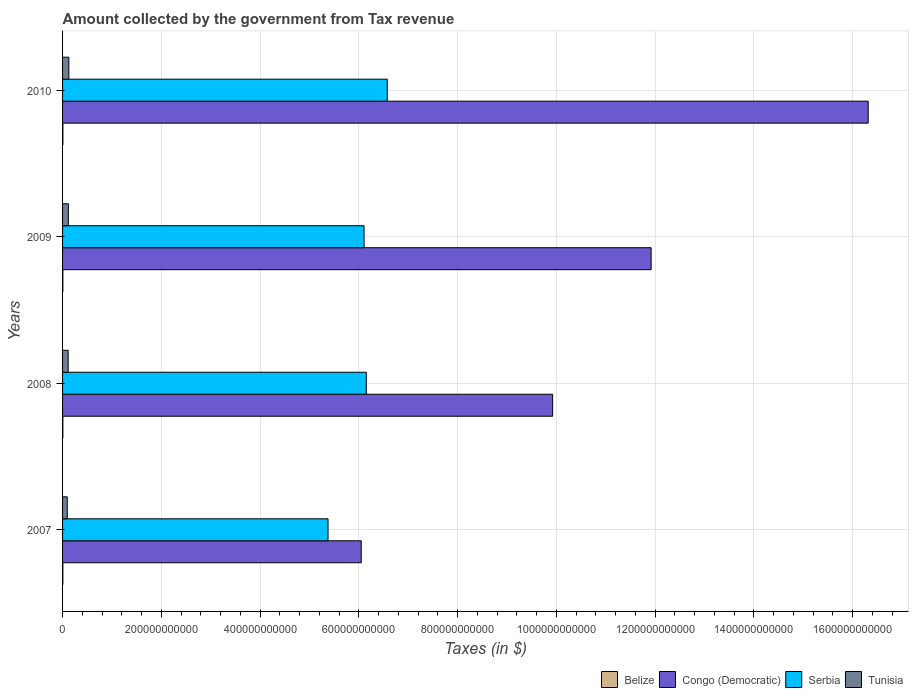What is the label of the 4th group of bars from the top?
Keep it short and to the point. 2007. In how many cases, is the number of bars for a given year not equal to the number of legend labels?
Keep it short and to the point. 0. What is the amount collected by the government from tax revenue in Tunisia in 2009?
Your answer should be compact. 1.18e+1. Across all years, what is the maximum amount collected by the government from tax revenue in Tunisia?
Provide a short and direct response. 1.27e+1. Across all years, what is the minimum amount collected by the government from tax revenue in Tunisia?
Offer a terse response. 9.51e+09. In which year was the amount collected by the government from tax revenue in Tunisia maximum?
Your answer should be compact. 2010. What is the total amount collected by the government from tax revenue in Belize in the graph?
Your response must be concise. 2.45e+09. What is the difference between the amount collected by the government from tax revenue in Serbia in 2009 and that in 2010?
Make the answer very short. -4.70e+1. What is the difference between the amount collected by the government from tax revenue in Serbia in 2010 and the amount collected by the government from tax revenue in Congo (Democratic) in 2008?
Provide a succinct answer. -3.35e+11. What is the average amount collected by the government from tax revenue in Serbia per year?
Give a very brief answer. 6.05e+11. In the year 2009, what is the difference between the amount collected by the government from tax revenue in Serbia and amount collected by the government from tax revenue in Belize?
Ensure brevity in your answer.  6.10e+11. What is the ratio of the amount collected by the government from tax revenue in Serbia in 2007 to that in 2010?
Your answer should be compact. 0.82. Is the amount collected by the government from tax revenue in Tunisia in 2009 less than that in 2010?
Your answer should be compact. Yes. Is the difference between the amount collected by the government from tax revenue in Serbia in 2007 and 2009 greater than the difference between the amount collected by the government from tax revenue in Belize in 2007 and 2009?
Your answer should be compact. No. What is the difference between the highest and the second highest amount collected by the government from tax revenue in Congo (Democratic)?
Give a very brief answer. 4.40e+11. What is the difference between the highest and the lowest amount collected by the government from tax revenue in Serbia?
Your response must be concise. 1.20e+11. In how many years, is the amount collected by the government from tax revenue in Belize greater than the average amount collected by the government from tax revenue in Belize taken over all years?
Your answer should be very brief. 1. Is it the case that in every year, the sum of the amount collected by the government from tax revenue in Belize and amount collected by the government from tax revenue in Congo (Democratic) is greater than the sum of amount collected by the government from tax revenue in Serbia and amount collected by the government from tax revenue in Tunisia?
Provide a short and direct response. Yes. What does the 2nd bar from the top in 2010 represents?
Make the answer very short. Serbia. What does the 3rd bar from the bottom in 2007 represents?
Make the answer very short. Serbia. Is it the case that in every year, the sum of the amount collected by the government from tax revenue in Serbia and amount collected by the government from tax revenue in Belize is greater than the amount collected by the government from tax revenue in Congo (Democratic)?
Provide a succinct answer. No. How many bars are there?
Your response must be concise. 16. Are all the bars in the graph horizontal?
Offer a very short reply. Yes. How many years are there in the graph?
Offer a terse response. 4. What is the difference between two consecutive major ticks on the X-axis?
Make the answer very short. 2.00e+11. What is the title of the graph?
Give a very brief answer. Amount collected by the government from Tax revenue. Does "Caribbean small states" appear as one of the legend labels in the graph?
Offer a terse response. No. What is the label or title of the X-axis?
Give a very brief answer. Taxes (in $). What is the Taxes (in $) in Belize in 2007?
Offer a terse response. 5.92e+08. What is the Taxes (in $) of Congo (Democratic) in 2007?
Offer a terse response. 6.05e+11. What is the Taxes (in $) of Serbia in 2007?
Keep it short and to the point. 5.38e+11. What is the Taxes (in $) in Tunisia in 2007?
Ensure brevity in your answer.  9.51e+09. What is the Taxes (in $) in Belize in 2008?
Make the answer very short. 5.94e+08. What is the Taxes (in $) of Congo (Democratic) in 2008?
Keep it short and to the point. 9.92e+11. What is the Taxes (in $) of Serbia in 2008?
Give a very brief answer. 6.15e+11. What is the Taxes (in $) in Tunisia in 2008?
Your answer should be compact. 1.13e+1. What is the Taxes (in $) of Belize in 2009?
Give a very brief answer. 6.01e+08. What is the Taxes (in $) in Congo (Democratic) in 2009?
Your response must be concise. 1.19e+12. What is the Taxes (in $) of Serbia in 2009?
Provide a short and direct response. 6.11e+11. What is the Taxes (in $) of Tunisia in 2009?
Keep it short and to the point. 1.18e+1. What is the Taxes (in $) of Belize in 2010?
Offer a terse response. 6.59e+08. What is the Taxes (in $) of Congo (Democratic) in 2010?
Keep it short and to the point. 1.63e+12. What is the Taxes (in $) in Serbia in 2010?
Your response must be concise. 6.58e+11. What is the Taxes (in $) in Tunisia in 2010?
Make the answer very short. 1.27e+1. Across all years, what is the maximum Taxes (in $) in Belize?
Provide a short and direct response. 6.59e+08. Across all years, what is the maximum Taxes (in $) in Congo (Democratic)?
Ensure brevity in your answer.  1.63e+12. Across all years, what is the maximum Taxes (in $) of Serbia?
Provide a short and direct response. 6.58e+11. Across all years, what is the maximum Taxes (in $) in Tunisia?
Provide a succinct answer. 1.27e+1. Across all years, what is the minimum Taxes (in $) in Belize?
Keep it short and to the point. 5.92e+08. Across all years, what is the minimum Taxes (in $) of Congo (Democratic)?
Offer a terse response. 6.05e+11. Across all years, what is the minimum Taxes (in $) of Serbia?
Provide a short and direct response. 5.38e+11. Across all years, what is the minimum Taxes (in $) of Tunisia?
Your answer should be compact. 9.51e+09. What is the total Taxes (in $) in Belize in the graph?
Offer a very short reply. 2.45e+09. What is the total Taxes (in $) of Congo (Democratic) in the graph?
Your answer should be very brief. 4.42e+12. What is the total Taxes (in $) of Serbia in the graph?
Keep it short and to the point. 2.42e+12. What is the total Taxes (in $) in Tunisia in the graph?
Provide a succinct answer. 4.53e+1. What is the difference between the Taxes (in $) in Belize in 2007 and that in 2008?
Keep it short and to the point. -2.30e+06. What is the difference between the Taxes (in $) of Congo (Democratic) in 2007 and that in 2008?
Provide a short and direct response. -3.88e+11. What is the difference between the Taxes (in $) of Serbia in 2007 and that in 2008?
Offer a very short reply. -7.75e+1. What is the difference between the Taxes (in $) in Tunisia in 2007 and that in 2008?
Your answer should be compact. -1.82e+09. What is the difference between the Taxes (in $) in Belize in 2007 and that in 2009?
Make the answer very short. -9.46e+06. What is the difference between the Taxes (in $) in Congo (Democratic) in 2007 and that in 2009?
Provide a short and direct response. -5.87e+11. What is the difference between the Taxes (in $) in Serbia in 2007 and that in 2009?
Give a very brief answer. -7.30e+1. What is the difference between the Taxes (in $) in Tunisia in 2007 and that in 2009?
Give a very brief answer. -2.26e+09. What is the difference between the Taxes (in $) of Belize in 2007 and that in 2010?
Your answer should be compact. -6.77e+07. What is the difference between the Taxes (in $) of Congo (Democratic) in 2007 and that in 2010?
Provide a short and direct response. -1.03e+12. What is the difference between the Taxes (in $) of Serbia in 2007 and that in 2010?
Your answer should be very brief. -1.20e+11. What is the difference between the Taxes (in $) of Tunisia in 2007 and that in 2010?
Offer a very short reply. -3.19e+09. What is the difference between the Taxes (in $) in Belize in 2008 and that in 2009?
Your answer should be compact. -7.17e+06. What is the difference between the Taxes (in $) in Congo (Democratic) in 2008 and that in 2009?
Your answer should be very brief. -1.99e+11. What is the difference between the Taxes (in $) in Serbia in 2008 and that in 2009?
Make the answer very short. 4.50e+09. What is the difference between the Taxes (in $) of Tunisia in 2008 and that in 2009?
Ensure brevity in your answer.  -4.33e+08. What is the difference between the Taxes (in $) of Belize in 2008 and that in 2010?
Make the answer very short. -6.54e+07. What is the difference between the Taxes (in $) in Congo (Democratic) in 2008 and that in 2010?
Offer a very short reply. -6.39e+11. What is the difference between the Taxes (in $) in Serbia in 2008 and that in 2010?
Provide a short and direct response. -4.25e+1. What is the difference between the Taxes (in $) in Tunisia in 2008 and that in 2010?
Keep it short and to the point. -1.37e+09. What is the difference between the Taxes (in $) of Belize in 2009 and that in 2010?
Your answer should be very brief. -5.82e+07. What is the difference between the Taxes (in $) in Congo (Democratic) in 2009 and that in 2010?
Your response must be concise. -4.40e+11. What is the difference between the Taxes (in $) of Serbia in 2009 and that in 2010?
Your response must be concise. -4.70e+1. What is the difference between the Taxes (in $) of Tunisia in 2009 and that in 2010?
Give a very brief answer. -9.35e+08. What is the difference between the Taxes (in $) in Belize in 2007 and the Taxes (in $) in Congo (Democratic) in 2008?
Offer a terse response. -9.92e+11. What is the difference between the Taxes (in $) in Belize in 2007 and the Taxes (in $) in Serbia in 2008?
Give a very brief answer. -6.14e+11. What is the difference between the Taxes (in $) of Belize in 2007 and the Taxes (in $) of Tunisia in 2008?
Your response must be concise. -1.07e+1. What is the difference between the Taxes (in $) in Congo (Democratic) in 2007 and the Taxes (in $) in Serbia in 2008?
Offer a very short reply. -1.03e+1. What is the difference between the Taxes (in $) in Congo (Democratic) in 2007 and the Taxes (in $) in Tunisia in 2008?
Keep it short and to the point. 5.93e+11. What is the difference between the Taxes (in $) of Serbia in 2007 and the Taxes (in $) of Tunisia in 2008?
Your response must be concise. 5.26e+11. What is the difference between the Taxes (in $) in Belize in 2007 and the Taxes (in $) in Congo (Democratic) in 2009?
Offer a terse response. -1.19e+12. What is the difference between the Taxes (in $) of Belize in 2007 and the Taxes (in $) of Serbia in 2009?
Ensure brevity in your answer.  -6.10e+11. What is the difference between the Taxes (in $) of Belize in 2007 and the Taxes (in $) of Tunisia in 2009?
Provide a succinct answer. -1.12e+1. What is the difference between the Taxes (in $) in Congo (Democratic) in 2007 and the Taxes (in $) in Serbia in 2009?
Provide a succinct answer. -5.83e+09. What is the difference between the Taxes (in $) in Congo (Democratic) in 2007 and the Taxes (in $) in Tunisia in 2009?
Make the answer very short. 5.93e+11. What is the difference between the Taxes (in $) in Serbia in 2007 and the Taxes (in $) in Tunisia in 2009?
Your response must be concise. 5.26e+11. What is the difference between the Taxes (in $) of Belize in 2007 and the Taxes (in $) of Congo (Democratic) in 2010?
Offer a terse response. -1.63e+12. What is the difference between the Taxes (in $) of Belize in 2007 and the Taxes (in $) of Serbia in 2010?
Your answer should be compact. -6.57e+11. What is the difference between the Taxes (in $) in Belize in 2007 and the Taxes (in $) in Tunisia in 2010?
Your answer should be very brief. -1.21e+1. What is the difference between the Taxes (in $) in Congo (Democratic) in 2007 and the Taxes (in $) in Serbia in 2010?
Offer a terse response. -5.28e+1. What is the difference between the Taxes (in $) of Congo (Democratic) in 2007 and the Taxes (in $) of Tunisia in 2010?
Offer a very short reply. 5.92e+11. What is the difference between the Taxes (in $) of Serbia in 2007 and the Taxes (in $) of Tunisia in 2010?
Your answer should be compact. 5.25e+11. What is the difference between the Taxes (in $) in Belize in 2008 and the Taxes (in $) in Congo (Democratic) in 2009?
Make the answer very short. -1.19e+12. What is the difference between the Taxes (in $) in Belize in 2008 and the Taxes (in $) in Serbia in 2009?
Give a very brief answer. -6.10e+11. What is the difference between the Taxes (in $) of Belize in 2008 and the Taxes (in $) of Tunisia in 2009?
Offer a very short reply. -1.12e+1. What is the difference between the Taxes (in $) of Congo (Democratic) in 2008 and the Taxes (in $) of Serbia in 2009?
Provide a succinct answer. 3.82e+11. What is the difference between the Taxes (in $) of Congo (Democratic) in 2008 and the Taxes (in $) of Tunisia in 2009?
Offer a terse response. 9.81e+11. What is the difference between the Taxes (in $) in Serbia in 2008 and the Taxes (in $) in Tunisia in 2009?
Provide a succinct answer. 6.03e+11. What is the difference between the Taxes (in $) in Belize in 2008 and the Taxes (in $) in Congo (Democratic) in 2010?
Offer a very short reply. -1.63e+12. What is the difference between the Taxes (in $) in Belize in 2008 and the Taxes (in $) in Serbia in 2010?
Your answer should be compact. -6.57e+11. What is the difference between the Taxes (in $) of Belize in 2008 and the Taxes (in $) of Tunisia in 2010?
Your answer should be compact. -1.21e+1. What is the difference between the Taxes (in $) of Congo (Democratic) in 2008 and the Taxes (in $) of Serbia in 2010?
Give a very brief answer. 3.35e+11. What is the difference between the Taxes (in $) in Congo (Democratic) in 2008 and the Taxes (in $) in Tunisia in 2010?
Keep it short and to the point. 9.80e+11. What is the difference between the Taxes (in $) in Serbia in 2008 and the Taxes (in $) in Tunisia in 2010?
Offer a very short reply. 6.02e+11. What is the difference between the Taxes (in $) of Belize in 2009 and the Taxes (in $) of Congo (Democratic) in 2010?
Your response must be concise. -1.63e+12. What is the difference between the Taxes (in $) of Belize in 2009 and the Taxes (in $) of Serbia in 2010?
Your answer should be compact. -6.57e+11. What is the difference between the Taxes (in $) in Belize in 2009 and the Taxes (in $) in Tunisia in 2010?
Your response must be concise. -1.21e+1. What is the difference between the Taxes (in $) of Congo (Democratic) in 2009 and the Taxes (in $) of Serbia in 2010?
Make the answer very short. 5.34e+11. What is the difference between the Taxes (in $) in Congo (Democratic) in 2009 and the Taxes (in $) in Tunisia in 2010?
Ensure brevity in your answer.  1.18e+12. What is the difference between the Taxes (in $) in Serbia in 2009 and the Taxes (in $) in Tunisia in 2010?
Provide a short and direct response. 5.98e+11. What is the average Taxes (in $) of Belize per year?
Offer a terse response. 6.12e+08. What is the average Taxes (in $) of Congo (Democratic) per year?
Ensure brevity in your answer.  1.11e+12. What is the average Taxes (in $) in Serbia per year?
Offer a terse response. 6.05e+11. What is the average Taxes (in $) in Tunisia per year?
Make the answer very short. 1.13e+1. In the year 2007, what is the difference between the Taxes (in $) in Belize and Taxes (in $) in Congo (Democratic)?
Ensure brevity in your answer.  -6.04e+11. In the year 2007, what is the difference between the Taxes (in $) of Belize and Taxes (in $) of Serbia?
Provide a succinct answer. -5.37e+11. In the year 2007, what is the difference between the Taxes (in $) of Belize and Taxes (in $) of Tunisia?
Your answer should be very brief. -8.92e+09. In the year 2007, what is the difference between the Taxes (in $) of Congo (Democratic) and Taxes (in $) of Serbia?
Give a very brief answer. 6.72e+1. In the year 2007, what is the difference between the Taxes (in $) of Congo (Democratic) and Taxes (in $) of Tunisia?
Your answer should be compact. 5.95e+11. In the year 2007, what is the difference between the Taxes (in $) of Serbia and Taxes (in $) of Tunisia?
Offer a terse response. 5.28e+11. In the year 2008, what is the difference between the Taxes (in $) in Belize and Taxes (in $) in Congo (Democratic)?
Offer a terse response. -9.92e+11. In the year 2008, what is the difference between the Taxes (in $) in Belize and Taxes (in $) in Serbia?
Your answer should be very brief. -6.14e+11. In the year 2008, what is the difference between the Taxes (in $) of Belize and Taxes (in $) of Tunisia?
Give a very brief answer. -1.07e+1. In the year 2008, what is the difference between the Taxes (in $) of Congo (Democratic) and Taxes (in $) of Serbia?
Your response must be concise. 3.77e+11. In the year 2008, what is the difference between the Taxes (in $) of Congo (Democratic) and Taxes (in $) of Tunisia?
Give a very brief answer. 9.81e+11. In the year 2008, what is the difference between the Taxes (in $) of Serbia and Taxes (in $) of Tunisia?
Give a very brief answer. 6.04e+11. In the year 2009, what is the difference between the Taxes (in $) of Belize and Taxes (in $) of Congo (Democratic)?
Your response must be concise. -1.19e+12. In the year 2009, what is the difference between the Taxes (in $) of Belize and Taxes (in $) of Serbia?
Give a very brief answer. -6.10e+11. In the year 2009, what is the difference between the Taxes (in $) in Belize and Taxes (in $) in Tunisia?
Provide a succinct answer. -1.12e+1. In the year 2009, what is the difference between the Taxes (in $) of Congo (Democratic) and Taxes (in $) of Serbia?
Your answer should be compact. 5.81e+11. In the year 2009, what is the difference between the Taxes (in $) of Congo (Democratic) and Taxes (in $) of Tunisia?
Your response must be concise. 1.18e+12. In the year 2009, what is the difference between the Taxes (in $) of Serbia and Taxes (in $) of Tunisia?
Your answer should be compact. 5.99e+11. In the year 2010, what is the difference between the Taxes (in $) in Belize and Taxes (in $) in Congo (Democratic)?
Offer a very short reply. -1.63e+12. In the year 2010, what is the difference between the Taxes (in $) in Belize and Taxes (in $) in Serbia?
Your answer should be compact. -6.57e+11. In the year 2010, what is the difference between the Taxes (in $) of Belize and Taxes (in $) of Tunisia?
Offer a terse response. -1.20e+1. In the year 2010, what is the difference between the Taxes (in $) of Congo (Democratic) and Taxes (in $) of Serbia?
Make the answer very short. 9.74e+11. In the year 2010, what is the difference between the Taxes (in $) in Congo (Democratic) and Taxes (in $) in Tunisia?
Offer a very short reply. 1.62e+12. In the year 2010, what is the difference between the Taxes (in $) of Serbia and Taxes (in $) of Tunisia?
Your answer should be very brief. 6.45e+11. What is the ratio of the Taxes (in $) of Congo (Democratic) in 2007 to that in 2008?
Keep it short and to the point. 0.61. What is the ratio of the Taxes (in $) in Serbia in 2007 to that in 2008?
Your answer should be compact. 0.87. What is the ratio of the Taxes (in $) of Tunisia in 2007 to that in 2008?
Provide a succinct answer. 0.84. What is the ratio of the Taxes (in $) of Belize in 2007 to that in 2009?
Provide a succinct answer. 0.98. What is the ratio of the Taxes (in $) in Congo (Democratic) in 2007 to that in 2009?
Give a very brief answer. 0.51. What is the ratio of the Taxes (in $) of Serbia in 2007 to that in 2009?
Your answer should be very brief. 0.88. What is the ratio of the Taxes (in $) in Tunisia in 2007 to that in 2009?
Your answer should be very brief. 0.81. What is the ratio of the Taxes (in $) of Belize in 2007 to that in 2010?
Make the answer very short. 0.9. What is the ratio of the Taxes (in $) in Congo (Democratic) in 2007 to that in 2010?
Keep it short and to the point. 0.37. What is the ratio of the Taxes (in $) of Serbia in 2007 to that in 2010?
Ensure brevity in your answer.  0.82. What is the ratio of the Taxes (in $) of Tunisia in 2007 to that in 2010?
Provide a succinct answer. 0.75. What is the ratio of the Taxes (in $) in Congo (Democratic) in 2008 to that in 2009?
Provide a short and direct response. 0.83. What is the ratio of the Taxes (in $) in Serbia in 2008 to that in 2009?
Make the answer very short. 1.01. What is the ratio of the Taxes (in $) of Tunisia in 2008 to that in 2009?
Make the answer very short. 0.96. What is the ratio of the Taxes (in $) of Belize in 2008 to that in 2010?
Provide a short and direct response. 0.9. What is the ratio of the Taxes (in $) of Congo (Democratic) in 2008 to that in 2010?
Provide a succinct answer. 0.61. What is the ratio of the Taxes (in $) in Serbia in 2008 to that in 2010?
Keep it short and to the point. 0.94. What is the ratio of the Taxes (in $) in Tunisia in 2008 to that in 2010?
Make the answer very short. 0.89. What is the ratio of the Taxes (in $) of Belize in 2009 to that in 2010?
Your response must be concise. 0.91. What is the ratio of the Taxes (in $) of Congo (Democratic) in 2009 to that in 2010?
Your response must be concise. 0.73. What is the ratio of the Taxes (in $) of Serbia in 2009 to that in 2010?
Your response must be concise. 0.93. What is the ratio of the Taxes (in $) in Tunisia in 2009 to that in 2010?
Offer a very short reply. 0.93. What is the difference between the highest and the second highest Taxes (in $) of Belize?
Ensure brevity in your answer.  5.82e+07. What is the difference between the highest and the second highest Taxes (in $) of Congo (Democratic)?
Offer a very short reply. 4.40e+11. What is the difference between the highest and the second highest Taxes (in $) in Serbia?
Ensure brevity in your answer.  4.25e+1. What is the difference between the highest and the second highest Taxes (in $) in Tunisia?
Offer a very short reply. 9.35e+08. What is the difference between the highest and the lowest Taxes (in $) in Belize?
Ensure brevity in your answer.  6.77e+07. What is the difference between the highest and the lowest Taxes (in $) in Congo (Democratic)?
Provide a short and direct response. 1.03e+12. What is the difference between the highest and the lowest Taxes (in $) of Serbia?
Your response must be concise. 1.20e+11. What is the difference between the highest and the lowest Taxes (in $) in Tunisia?
Provide a short and direct response. 3.19e+09. 